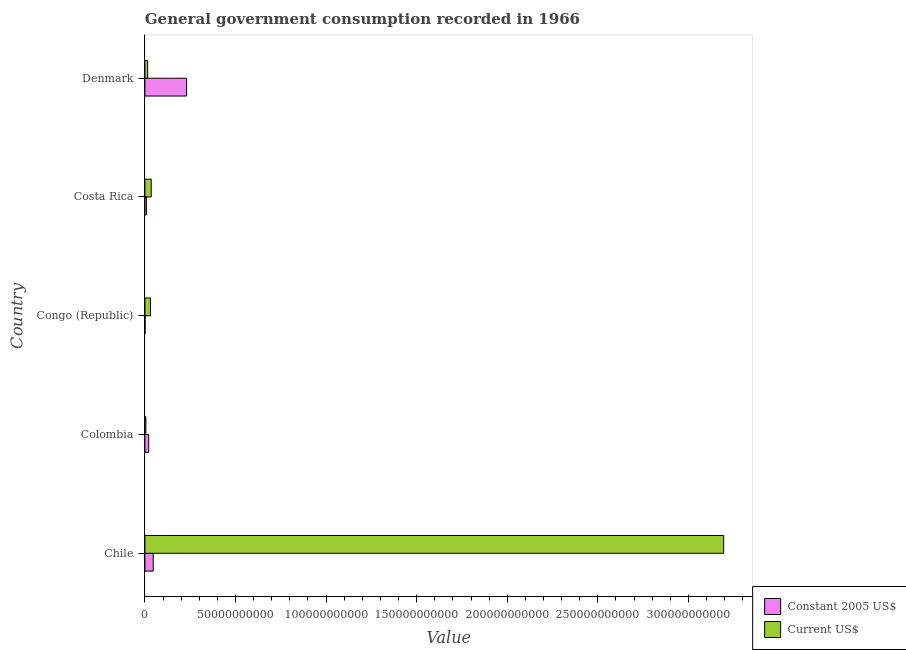How many groups of bars are there?
Your answer should be very brief. 5. How many bars are there on the 4th tick from the top?
Your answer should be compact. 2. How many bars are there on the 3rd tick from the bottom?
Provide a short and direct response. 2. What is the label of the 2nd group of bars from the top?
Give a very brief answer. Costa Rica. In how many cases, is the number of bars for a given country not equal to the number of legend labels?
Ensure brevity in your answer.  0. What is the value consumed in constant 2005 us$ in Costa Rica?
Ensure brevity in your answer.  8.32e+08. Across all countries, what is the maximum value consumed in current us$?
Your answer should be very brief. 3.19e+11. Across all countries, what is the minimum value consumed in current us$?
Keep it short and to the point. 5.36e+08. In which country was the value consumed in current us$ minimum?
Offer a terse response. Colombia. What is the total value consumed in current us$ in the graph?
Offer a terse response. 3.28e+11. What is the difference between the value consumed in current us$ in Chile and that in Costa Rica?
Offer a very short reply. 3.16e+11. What is the difference between the value consumed in constant 2005 us$ in Colombia and the value consumed in current us$ in Congo (Republic)?
Your response must be concise. -1.01e+09. What is the average value consumed in constant 2005 us$ per country?
Provide a succinct answer. 6.12e+09. What is the difference between the value consumed in constant 2005 us$ and value consumed in current us$ in Costa Rica?
Offer a terse response. -2.64e+09. In how many countries, is the value consumed in constant 2005 us$ greater than 210000000000 ?
Give a very brief answer. 0. What is the ratio of the value consumed in constant 2005 us$ in Chile to that in Colombia?
Offer a very short reply. 2.2. Is the value consumed in current us$ in Costa Rica less than that in Denmark?
Offer a terse response. No. What is the difference between the highest and the second highest value consumed in current us$?
Your answer should be very brief. 3.16e+11. What is the difference between the highest and the lowest value consumed in current us$?
Give a very brief answer. 3.19e+11. What does the 2nd bar from the top in Chile represents?
Your answer should be compact. Constant 2005 US$. What does the 2nd bar from the bottom in Chile represents?
Make the answer very short. Current US$. Are the values on the major ticks of X-axis written in scientific E-notation?
Offer a terse response. No. Where does the legend appear in the graph?
Your answer should be compact. Bottom right. How are the legend labels stacked?
Provide a succinct answer. Vertical. What is the title of the graph?
Your answer should be very brief. General government consumption recorded in 1966. What is the label or title of the X-axis?
Make the answer very short. Value. What is the Value of Constant 2005 US$ in Chile?
Provide a short and direct response. 4.58e+09. What is the Value of Current US$ in Chile?
Make the answer very short. 3.19e+11. What is the Value of Constant 2005 US$ in Colombia?
Offer a very short reply. 2.08e+09. What is the Value of Current US$ in Colombia?
Give a very brief answer. 5.36e+08. What is the Value of Constant 2005 US$ in Congo (Republic)?
Provide a succinct answer. 1.07e+08. What is the Value of Current US$ in Congo (Republic)?
Offer a very short reply. 3.09e+09. What is the Value of Constant 2005 US$ in Costa Rica?
Your answer should be very brief. 8.32e+08. What is the Value in Current US$ in Costa Rica?
Offer a terse response. 3.47e+09. What is the Value in Constant 2005 US$ in Denmark?
Give a very brief answer. 2.30e+1. What is the Value in Current US$ in Denmark?
Ensure brevity in your answer.  1.49e+09. Across all countries, what is the maximum Value in Constant 2005 US$?
Make the answer very short. 2.30e+1. Across all countries, what is the maximum Value of Current US$?
Keep it short and to the point. 3.19e+11. Across all countries, what is the minimum Value in Constant 2005 US$?
Make the answer very short. 1.07e+08. Across all countries, what is the minimum Value in Current US$?
Your answer should be compact. 5.36e+08. What is the total Value of Constant 2005 US$ in the graph?
Your response must be concise. 3.06e+1. What is the total Value of Current US$ in the graph?
Keep it short and to the point. 3.28e+11. What is the difference between the Value in Constant 2005 US$ in Chile and that in Colombia?
Ensure brevity in your answer.  2.50e+09. What is the difference between the Value in Current US$ in Chile and that in Colombia?
Offer a terse response. 3.19e+11. What is the difference between the Value in Constant 2005 US$ in Chile and that in Congo (Republic)?
Ensure brevity in your answer.  4.47e+09. What is the difference between the Value in Current US$ in Chile and that in Congo (Republic)?
Make the answer very short. 3.16e+11. What is the difference between the Value in Constant 2005 US$ in Chile and that in Costa Rica?
Provide a succinct answer. 3.75e+09. What is the difference between the Value in Current US$ in Chile and that in Costa Rica?
Offer a very short reply. 3.16e+11. What is the difference between the Value in Constant 2005 US$ in Chile and that in Denmark?
Keep it short and to the point. -1.84e+1. What is the difference between the Value in Current US$ in Chile and that in Denmark?
Ensure brevity in your answer.  3.18e+11. What is the difference between the Value of Constant 2005 US$ in Colombia and that in Congo (Republic)?
Offer a terse response. 1.97e+09. What is the difference between the Value of Current US$ in Colombia and that in Congo (Republic)?
Give a very brief answer. -2.56e+09. What is the difference between the Value in Constant 2005 US$ in Colombia and that in Costa Rica?
Offer a very short reply. 1.25e+09. What is the difference between the Value in Current US$ in Colombia and that in Costa Rica?
Your response must be concise. -2.94e+09. What is the difference between the Value in Constant 2005 US$ in Colombia and that in Denmark?
Your answer should be very brief. -2.09e+1. What is the difference between the Value in Current US$ in Colombia and that in Denmark?
Give a very brief answer. -9.59e+08. What is the difference between the Value in Constant 2005 US$ in Congo (Republic) and that in Costa Rica?
Give a very brief answer. -7.25e+08. What is the difference between the Value of Current US$ in Congo (Republic) and that in Costa Rica?
Offer a terse response. -3.81e+08. What is the difference between the Value in Constant 2005 US$ in Congo (Republic) and that in Denmark?
Ensure brevity in your answer.  -2.29e+1. What is the difference between the Value of Current US$ in Congo (Republic) and that in Denmark?
Ensure brevity in your answer.  1.60e+09. What is the difference between the Value of Constant 2005 US$ in Costa Rica and that in Denmark?
Give a very brief answer. -2.22e+1. What is the difference between the Value of Current US$ in Costa Rica and that in Denmark?
Provide a short and direct response. 1.98e+09. What is the difference between the Value in Constant 2005 US$ in Chile and the Value in Current US$ in Colombia?
Ensure brevity in your answer.  4.04e+09. What is the difference between the Value of Constant 2005 US$ in Chile and the Value of Current US$ in Congo (Republic)?
Keep it short and to the point. 1.49e+09. What is the difference between the Value in Constant 2005 US$ in Chile and the Value in Current US$ in Costa Rica?
Your response must be concise. 1.10e+09. What is the difference between the Value of Constant 2005 US$ in Chile and the Value of Current US$ in Denmark?
Provide a succinct answer. 3.08e+09. What is the difference between the Value in Constant 2005 US$ in Colombia and the Value in Current US$ in Congo (Republic)?
Make the answer very short. -1.01e+09. What is the difference between the Value in Constant 2005 US$ in Colombia and the Value in Current US$ in Costa Rica?
Offer a terse response. -1.40e+09. What is the difference between the Value in Constant 2005 US$ in Colombia and the Value in Current US$ in Denmark?
Make the answer very short. 5.84e+08. What is the difference between the Value in Constant 2005 US$ in Congo (Republic) and the Value in Current US$ in Costa Rica?
Keep it short and to the point. -3.37e+09. What is the difference between the Value in Constant 2005 US$ in Congo (Republic) and the Value in Current US$ in Denmark?
Provide a short and direct response. -1.39e+09. What is the difference between the Value of Constant 2005 US$ in Costa Rica and the Value of Current US$ in Denmark?
Provide a succinct answer. -6.63e+08. What is the average Value in Constant 2005 US$ per country?
Offer a very short reply. 6.12e+09. What is the average Value of Current US$ per country?
Your answer should be very brief. 6.56e+1. What is the difference between the Value of Constant 2005 US$ and Value of Current US$ in Chile?
Make the answer very short. -3.15e+11. What is the difference between the Value in Constant 2005 US$ and Value in Current US$ in Colombia?
Keep it short and to the point. 1.54e+09. What is the difference between the Value in Constant 2005 US$ and Value in Current US$ in Congo (Republic)?
Give a very brief answer. -2.99e+09. What is the difference between the Value of Constant 2005 US$ and Value of Current US$ in Costa Rica?
Offer a terse response. -2.64e+09. What is the difference between the Value of Constant 2005 US$ and Value of Current US$ in Denmark?
Your answer should be very brief. 2.15e+1. What is the ratio of the Value of Constant 2005 US$ in Chile to that in Colombia?
Your answer should be very brief. 2.2. What is the ratio of the Value in Current US$ in Chile to that in Colombia?
Make the answer very short. 596.04. What is the ratio of the Value in Constant 2005 US$ in Chile to that in Congo (Republic)?
Provide a short and direct response. 42.81. What is the ratio of the Value of Current US$ in Chile to that in Congo (Republic)?
Give a very brief answer. 103.29. What is the ratio of the Value of Constant 2005 US$ in Chile to that in Costa Rica?
Provide a short and direct response. 5.51. What is the ratio of the Value of Current US$ in Chile to that in Costa Rica?
Your answer should be very brief. 91.97. What is the ratio of the Value in Constant 2005 US$ in Chile to that in Denmark?
Your answer should be compact. 0.2. What is the ratio of the Value of Current US$ in Chile to that in Denmark?
Offer a terse response. 213.74. What is the ratio of the Value of Constant 2005 US$ in Colombia to that in Congo (Republic)?
Give a very brief answer. 19.44. What is the ratio of the Value of Current US$ in Colombia to that in Congo (Republic)?
Provide a short and direct response. 0.17. What is the ratio of the Value of Constant 2005 US$ in Colombia to that in Costa Rica?
Offer a terse response. 2.5. What is the ratio of the Value of Current US$ in Colombia to that in Costa Rica?
Your answer should be very brief. 0.15. What is the ratio of the Value in Constant 2005 US$ in Colombia to that in Denmark?
Offer a very short reply. 0.09. What is the ratio of the Value in Current US$ in Colombia to that in Denmark?
Your answer should be compact. 0.36. What is the ratio of the Value of Constant 2005 US$ in Congo (Republic) to that in Costa Rica?
Provide a succinct answer. 0.13. What is the ratio of the Value in Current US$ in Congo (Republic) to that in Costa Rica?
Keep it short and to the point. 0.89. What is the ratio of the Value in Constant 2005 US$ in Congo (Republic) to that in Denmark?
Give a very brief answer. 0. What is the ratio of the Value of Current US$ in Congo (Republic) to that in Denmark?
Provide a succinct answer. 2.07. What is the ratio of the Value of Constant 2005 US$ in Costa Rica to that in Denmark?
Provide a short and direct response. 0.04. What is the ratio of the Value of Current US$ in Costa Rica to that in Denmark?
Provide a short and direct response. 2.32. What is the difference between the highest and the second highest Value of Constant 2005 US$?
Make the answer very short. 1.84e+1. What is the difference between the highest and the second highest Value in Current US$?
Provide a short and direct response. 3.16e+11. What is the difference between the highest and the lowest Value of Constant 2005 US$?
Make the answer very short. 2.29e+1. What is the difference between the highest and the lowest Value in Current US$?
Your response must be concise. 3.19e+11. 